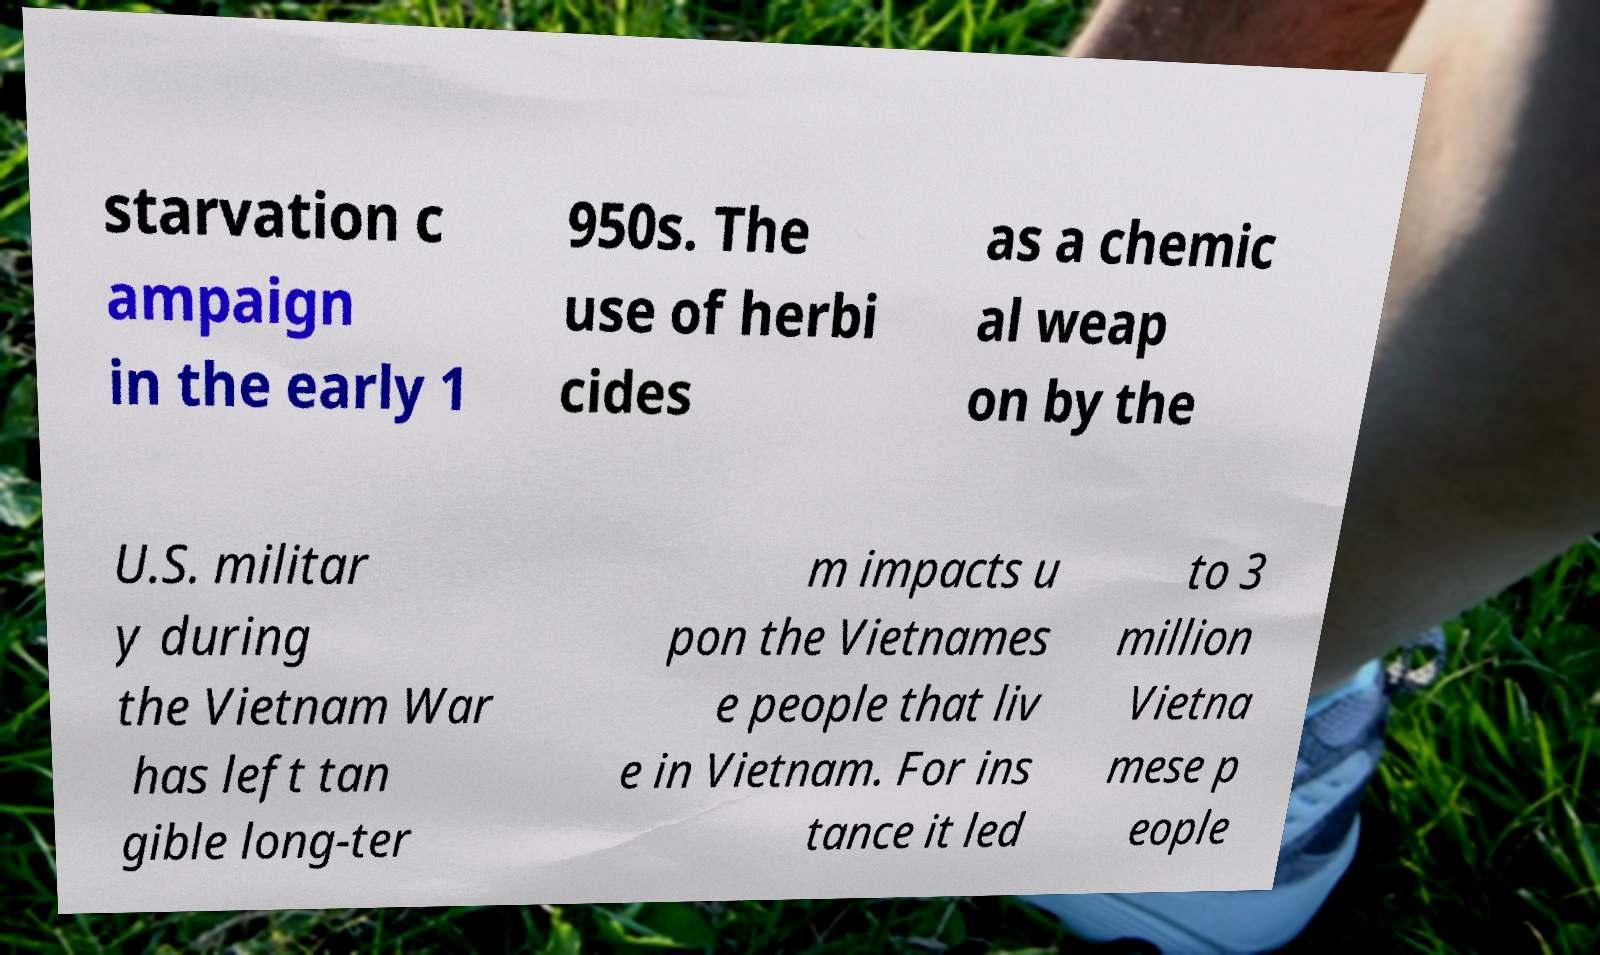There's text embedded in this image that I need extracted. Can you transcribe it verbatim? starvation c ampaign in the early 1 950s. The use of herbi cides as a chemic al weap on by the U.S. militar y during the Vietnam War has left tan gible long-ter m impacts u pon the Vietnames e people that liv e in Vietnam. For ins tance it led to 3 million Vietna mese p eople 